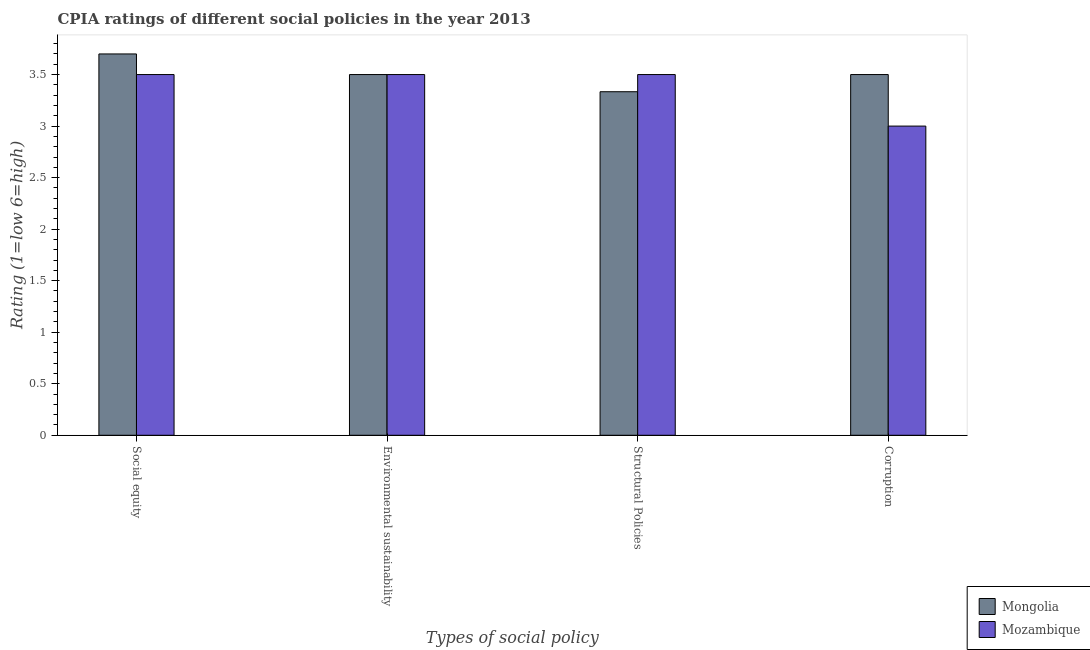How many groups of bars are there?
Keep it short and to the point. 4. Are the number of bars on each tick of the X-axis equal?
Ensure brevity in your answer.  Yes. How many bars are there on the 2nd tick from the left?
Provide a succinct answer. 2. How many bars are there on the 1st tick from the right?
Your answer should be very brief. 2. What is the label of the 2nd group of bars from the left?
Offer a terse response. Environmental sustainability. What is the cpia rating of structural policies in Mozambique?
Give a very brief answer. 3.5. Across all countries, what is the maximum cpia rating of corruption?
Ensure brevity in your answer.  3.5. In which country was the cpia rating of structural policies maximum?
Provide a succinct answer. Mozambique. In which country was the cpia rating of corruption minimum?
Offer a very short reply. Mozambique. What is the total cpia rating of environmental sustainability in the graph?
Make the answer very short. 7. What is the difference between the cpia rating of structural policies in Mozambique and that in Mongolia?
Your answer should be compact. 0.17. What is the difference between the cpia rating of social equity in Mongolia and the cpia rating of environmental sustainability in Mozambique?
Give a very brief answer. 0.2. What is the average cpia rating of structural policies per country?
Keep it short and to the point. 3.42. What is the difference between the cpia rating of structural policies and cpia rating of corruption in Mongolia?
Keep it short and to the point. -0.17. In how many countries, is the cpia rating of social equity greater than 0.30000000000000004 ?
Provide a succinct answer. 2. What is the ratio of the cpia rating of structural policies in Mozambique to that in Mongolia?
Provide a succinct answer. 1.05. Is the cpia rating of corruption in Mozambique less than that in Mongolia?
Your answer should be compact. Yes. Is the difference between the cpia rating of social equity in Mozambique and Mongolia greater than the difference between the cpia rating of structural policies in Mozambique and Mongolia?
Offer a very short reply. No. What is the difference between the highest and the second highest cpia rating of structural policies?
Keep it short and to the point. 0.17. What does the 1st bar from the left in Social equity represents?
Make the answer very short. Mongolia. What does the 1st bar from the right in Social equity represents?
Your response must be concise. Mozambique. Is it the case that in every country, the sum of the cpia rating of social equity and cpia rating of environmental sustainability is greater than the cpia rating of structural policies?
Keep it short and to the point. Yes. Are all the bars in the graph horizontal?
Offer a terse response. No. Are the values on the major ticks of Y-axis written in scientific E-notation?
Give a very brief answer. No. Does the graph contain any zero values?
Your answer should be compact. No. How many legend labels are there?
Keep it short and to the point. 2. How are the legend labels stacked?
Ensure brevity in your answer.  Vertical. What is the title of the graph?
Make the answer very short. CPIA ratings of different social policies in the year 2013. Does "Cuba" appear as one of the legend labels in the graph?
Your answer should be compact. No. What is the label or title of the X-axis?
Offer a terse response. Types of social policy. What is the Rating (1=low 6=high) of Mozambique in Social equity?
Provide a short and direct response. 3.5. What is the Rating (1=low 6=high) of Mongolia in Environmental sustainability?
Your answer should be very brief. 3.5. What is the Rating (1=low 6=high) in Mozambique in Environmental sustainability?
Your answer should be very brief. 3.5. What is the Rating (1=low 6=high) of Mongolia in Structural Policies?
Provide a succinct answer. 3.33. What is the Rating (1=low 6=high) of Mozambique in Structural Policies?
Make the answer very short. 3.5. Across all Types of social policy, what is the maximum Rating (1=low 6=high) of Mozambique?
Provide a succinct answer. 3.5. Across all Types of social policy, what is the minimum Rating (1=low 6=high) in Mongolia?
Give a very brief answer. 3.33. Across all Types of social policy, what is the minimum Rating (1=low 6=high) in Mozambique?
Your answer should be compact. 3. What is the total Rating (1=low 6=high) in Mongolia in the graph?
Offer a terse response. 14.03. What is the total Rating (1=low 6=high) in Mozambique in the graph?
Give a very brief answer. 13.5. What is the difference between the Rating (1=low 6=high) of Mongolia in Social equity and that in Environmental sustainability?
Your answer should be very brief. 0.2. What is the difference between the Rating (1=low 6=high) of Mozambique in Social equity and that in Environmental sustainability?
Your answer should be compact. 0. What is the difference between the Rating (1=low 6=high) in Mongolia in Social equity and that in Structural Policies?
Keep it short and to the point. 0.37. What is the difference between the Rating (1=low 6=high) in Mongolia in Social equity and that in Corruption?
Offer a very short reply. 0.2. What is the difference between the Rating (1=low 6=high) of Mongolia in Environmental sustainability and that in Structural Policies?
Ensure brevity in your answer.  0.17. What is the difference between the Rating (1=low 6=high) of Mozambique in Environmental sustainability and that in Structural Policies?
Offer a very short reply. 0. What is the difference between the Rating (1=low 6=high) in Mongolia in Environmental sustainability and that in Corruption?
Your answer should be very brief. 0. What is the difference between the Rating (1=low 6=high) of Mongolia in Structural Policies and that in Corruption?
Ensure brevity in your answer.  -0.17. What is the difference between the Rating (1=low 6=high) of Mongolia in Social equity and the Rating (1=low 6=high) of Mozambique in Environmental sustainability?
Make the answer very short. 0.2. What is the difference between the Rating (1=low 6=high) of Mongolia in Social equity and the Rating (1=low 6=high) of Mozambique in Structural Policies?
Make the answer very short. 0.2. What is the difference between the Rating (1=low 6=high) in Mongolia in Environmental sustainability and the Rating (1=low 6=high) in Mozambique in Structural Policies?
Your response must be concise. 0. What is the difference between the Rating (1=low 6=high) of Mongolia in Environmental sustainability and the Rating (1=low 6=high) of Mozambique in Corruption?
Make the answer very short. 0.5. What is the difference between the Rating (1=low 6=high) in Mongolia in Structural Policies and the Rating (1=low 6=high) in Mozambique in Corruption?
Your response must be concise. 0.33. What is the average Rating (1=low 6=high) of Mongolia per Types of social policy?
Give a very brief answer. 3.51. What is the average Rating (1=low 6=high) in Mozambique per Types of social policy?
Provide a short and direct response. 3.38. What is the difference between the Rating (1=low 6=high) of Mongolia and Rating (1=low 6=high) of Mozambique in Social equity?
Offer a terse response. 0.2. What is the difference between the Rating (1=low 6=high) in Mongolia and Rating (1=low 6=high) in Mozambique in Environmental sustainability?
Your answer should be very brief. 0. What is the difference between the Rating (1=low 6=high) in Mongolia and Rating (1=low 6=high) in Mozambique in Structural Policies?
Offer a very short reply. -0.17. What is the difference between the Rating (1=low 6=high) of Mongolia and Rating (1=low 6=high) of Mozambique in Corruption?
Give a very brief answer. 0.5. What is the ratio of the Rating (1=low 6=high) of Mongolia in Social equity to that in Environmental sustainability?
Provide a succinct answer. 1.06. What is the ratio of the Rating (1=low 6=high) in Mozambique in Social equity to that in Environmental sustainability?
Make the answer very short. 1. What is the ratio of the Rating (1=low 6=high) in Mongolia in Social equity to that in Structural Policies?
Provide a short and direct response. 1.11. What is the ratio of the Rating (1=low 6=high) of Mongolia in Social equity to that in Corruption?
Offer a terse response. 1.06. What is the ratio of the Rating (1=low 6=high) of Mozambique in Structural Policies to that in Corruption?
Make the answer very short. 1.17. What is the difference between the highest and the lowest Rating (1=low 6=high) of Mongolia?
Make the answer very short. 0.37. 